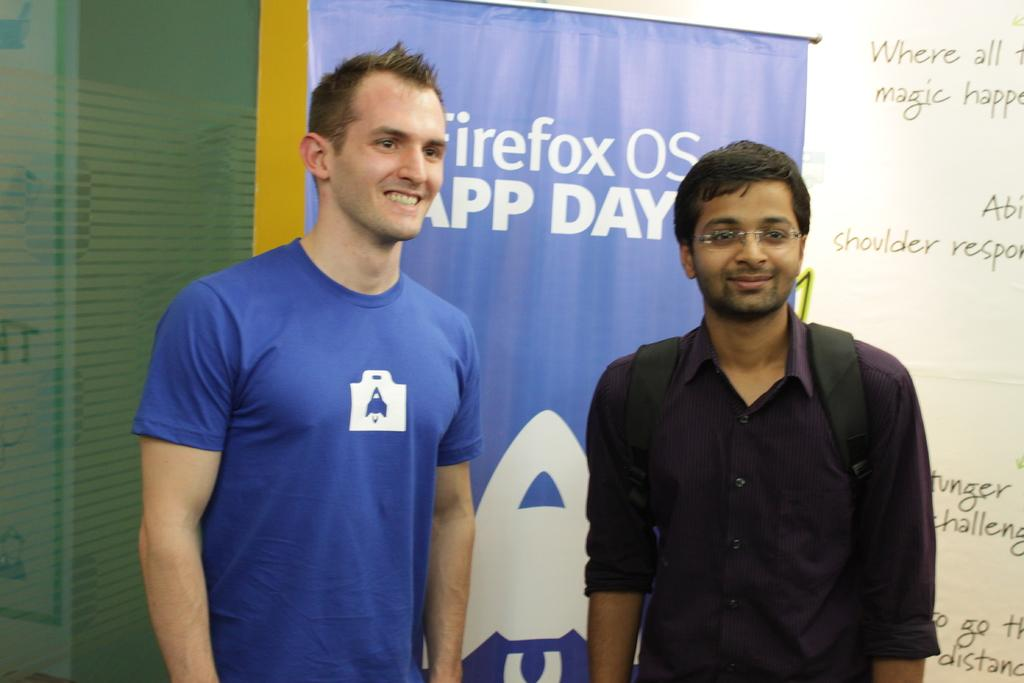<image>
Render a clear and concise summary of the photo. Two men stand side by side in front of a Firefox banner. 